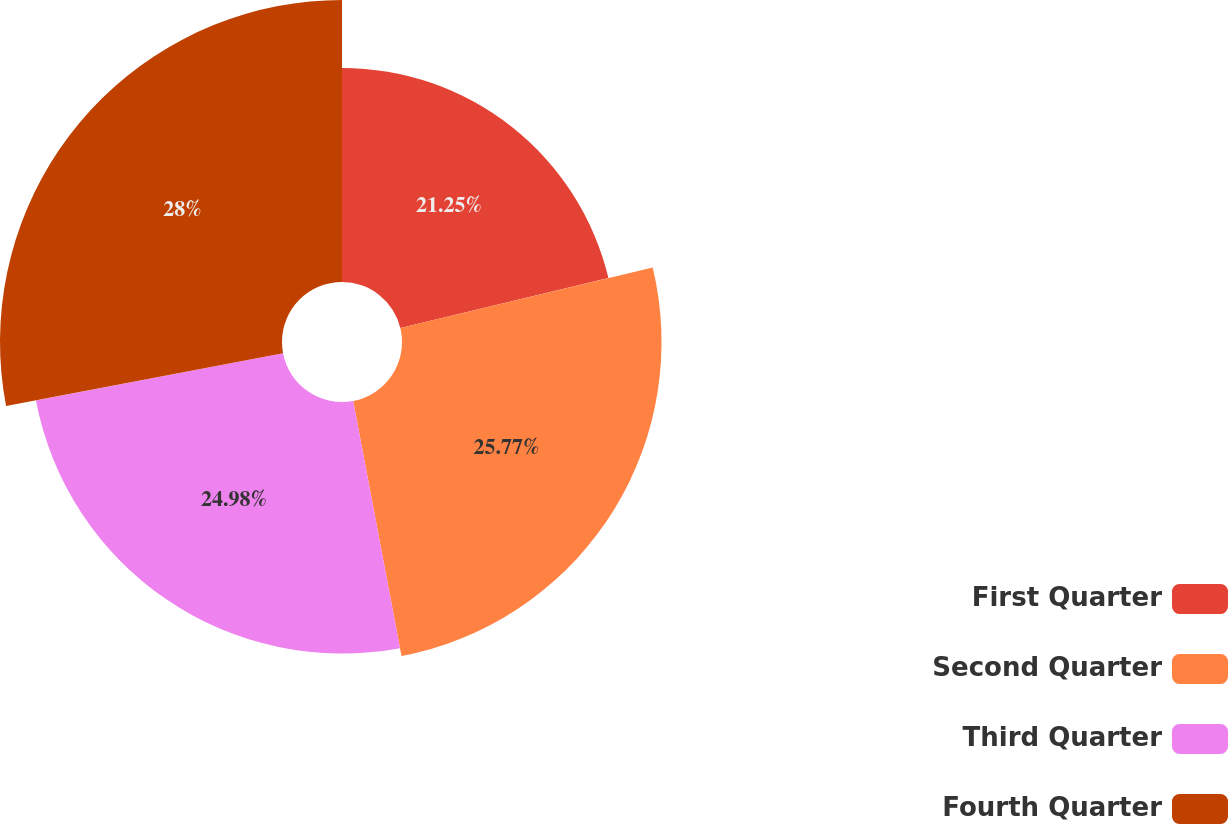<chart> <loc_0><loc_0><loc_500><loc_500><pie_chart><fcel>First Quarter<fcel>Second Quarter<fcel>Third Quarter<fcel>Fourth Quarter<nl><fcel>21.25%<fcel>25.77%<fcel>24.98%<fcel>28.0%<nl></chart> 